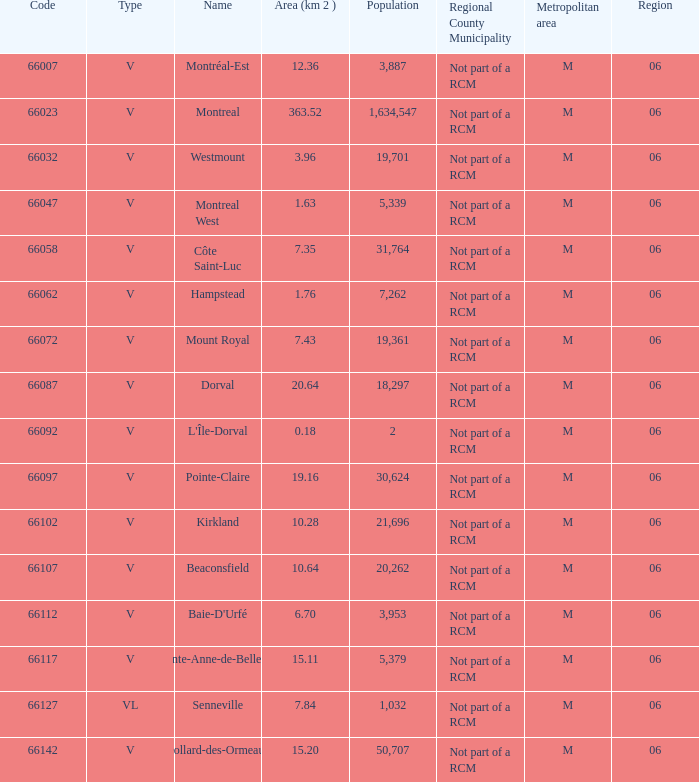What is the largest area with a Code of 66097, and a Region larger than 6? None. 